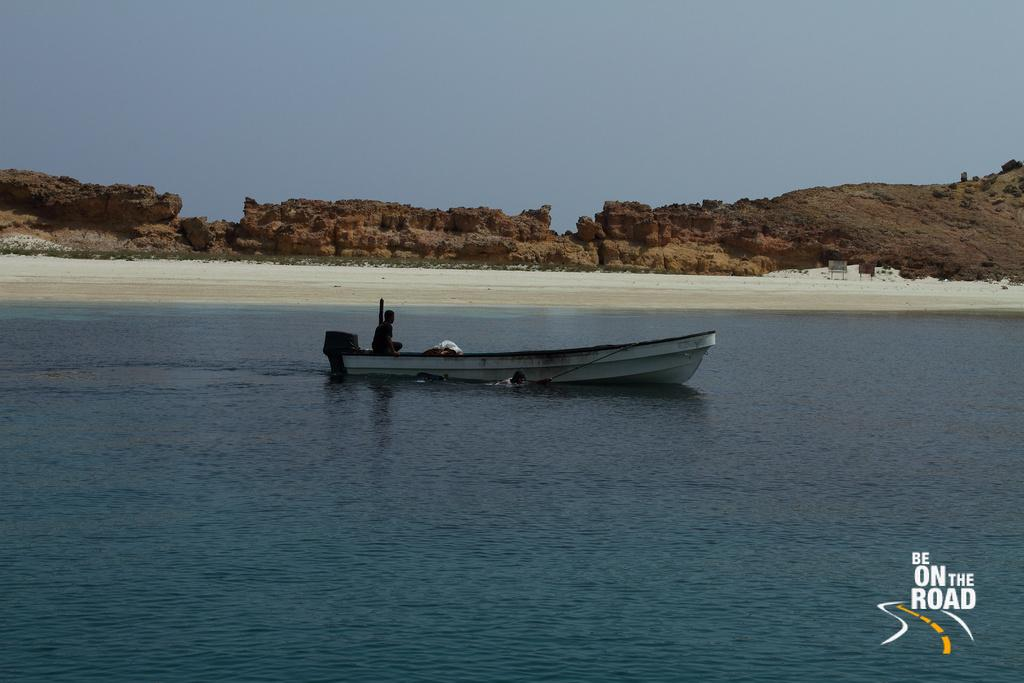What is the main feature of the image? There is water in the image. What is located on the water? There is a boat in the image. Who is in the boat? A person is sitting in the boat. What can be seen in the background of the image? There are mountains visible in the image. What is visible at the top of the image? The sky is visible at the top of the image. What type of popcorn is being served on the farm in the image? There is no popcorn or farm present in the image. How does the person in the boat react to the mountains in the image? The image does not show the person's reaction to the mountains, as it only depicts the person sitting in the boat. 